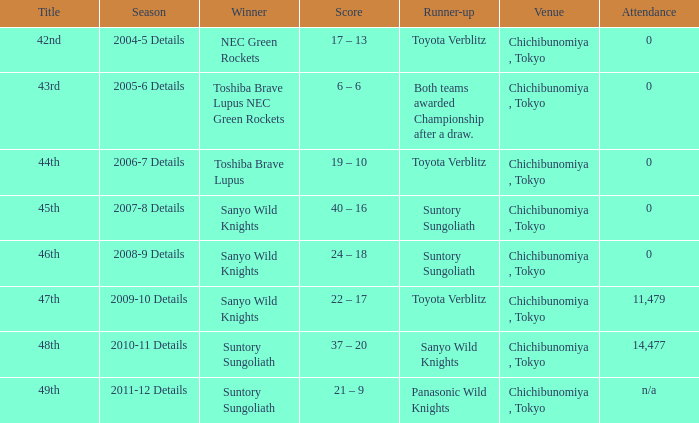What is the Title when the winner was suntory sungoliath, and a Season of 2011-12 details? 49th. 